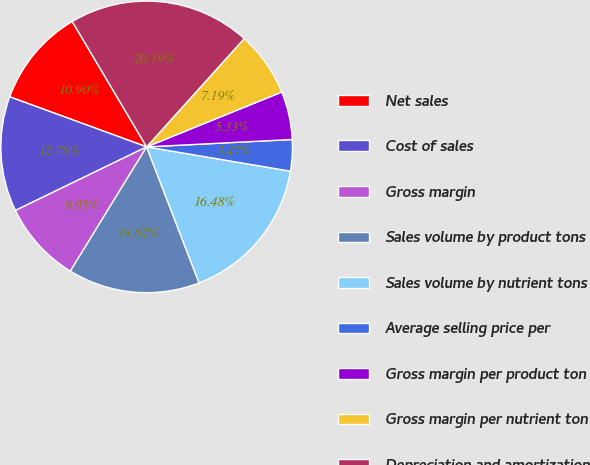Convert chart. <chart><loc_0><loc_0><loc_500><loc_500><pie_chart><fcel>Net sales<fcel>Cost of sales<fcel>Gross margin<fcel>Sales volume by product tons<fcel>Sales volume by nutrient tons<fcel>Average selling price per<fcel>Gross margin per product ton<fcel>Gross margin per nutrient ton<fcel>Depreciation and amortization<nl><fcel>10.9%<fcel>12.76%<fcel>9.05%<fcel>14.62%<fcel>16.48%<fcel>3.47%<fcel>5.33%<fcel>7.19%<fcel>20.19%<nl></chart> 